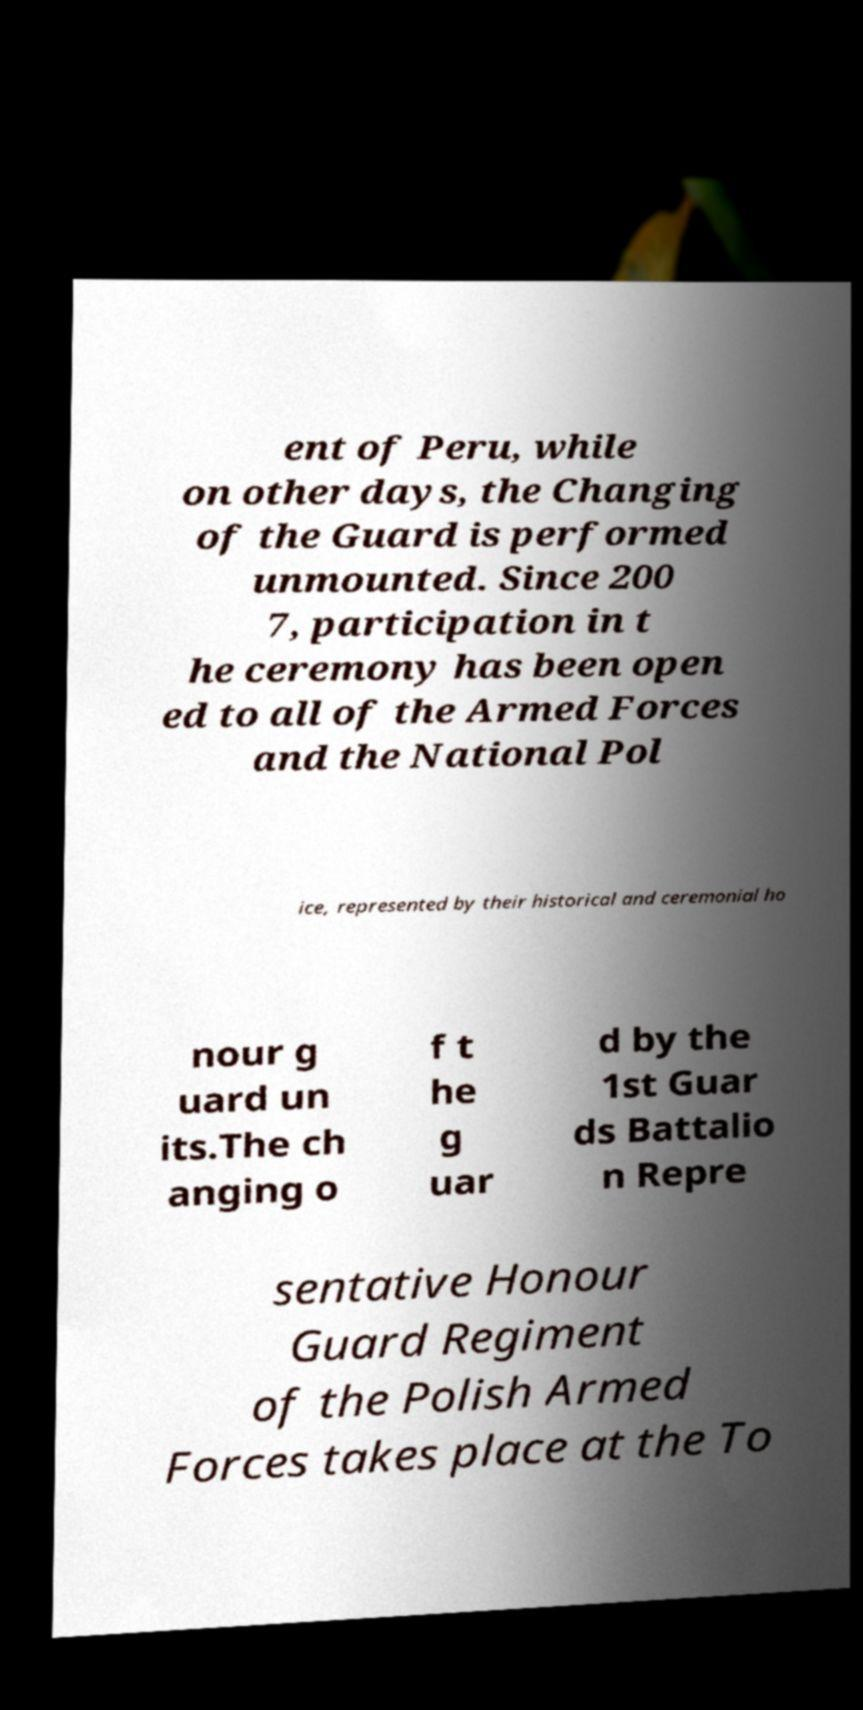What messages or text are displayed in this image? I need them in a readable, typed format. ent of Peru, while on other days, the Changing of the Guard is performed unmounted. Since 200 7, participation in t he ceremony has been open ed to all of the Armed Forces and the National Pol ice, represented by their historical and ceremonial ho nour g uard un its.The ch anging o f t he g uar d by the 1st Guar ds Battalio n Repre sentative Honour Guard Regiment of the Polish Armed Forces takes place at the To 